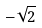Convert formula to latex. <formula><loc_0><loc_0><loc_500><loc_500>- \sqrt { 2 }</formula> 